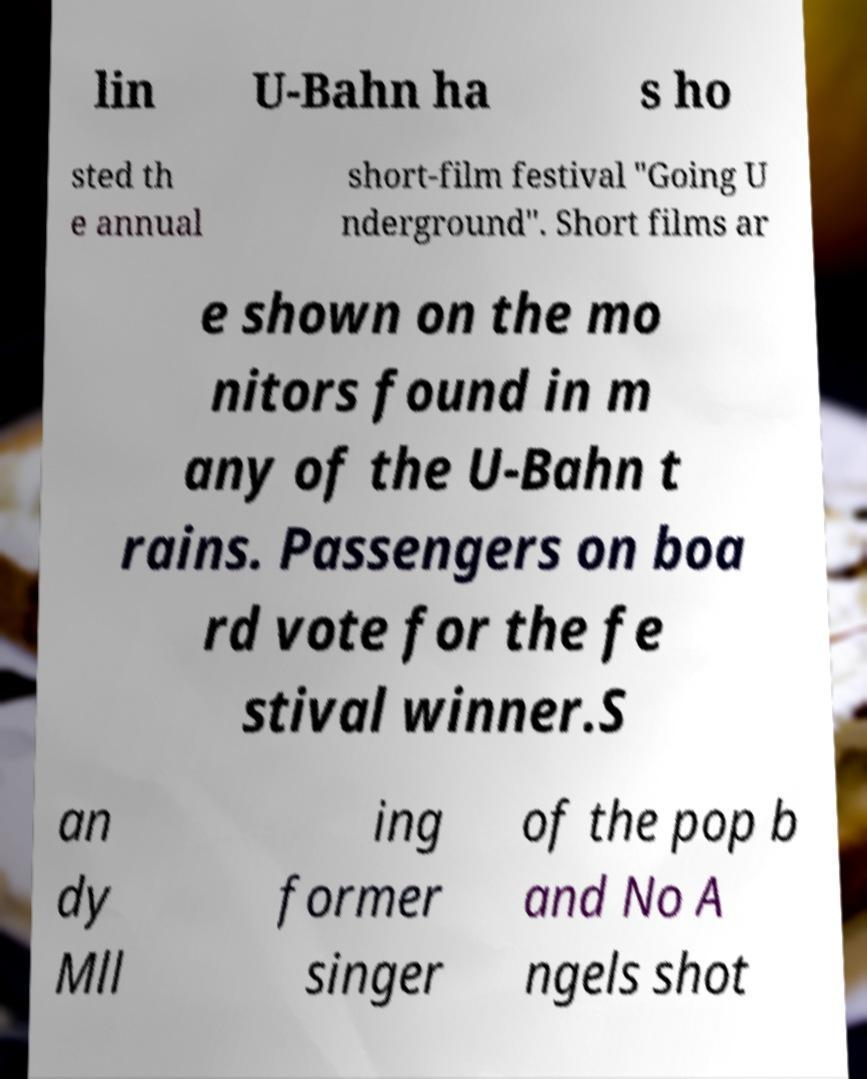Could you assist in decoding the text presented in this image and type it out clearly? lin U-Bahn ha s ho sted th e annual short-film festival "Going U nderground". Short films ar e shown on the mo nitors found in m any of the U-Bahn t rains. Passengers on boa rd vote for the fe stival winner.S an dy Mll ing former singer of the pop b and No A ngels shot 